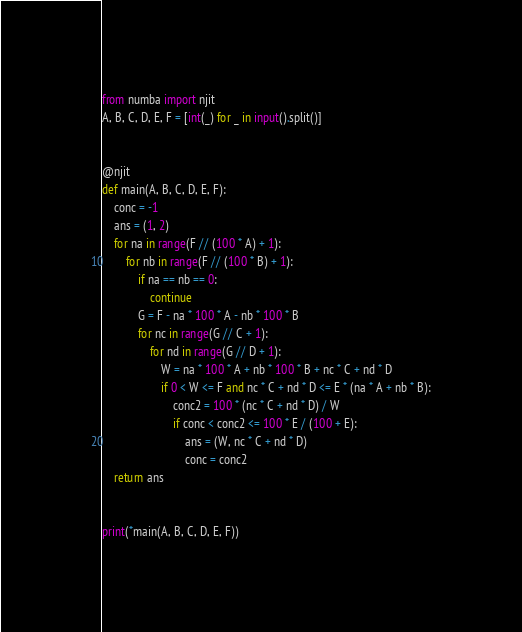Convert code to text. <code><loc_0><loc_0><loc_500><loc_500><_Python_>from numba import njit
A, B, C, D, E, F = [int(_) for _ in input().split()]


@njit
def main(A, B, C, D, E, F):
    conc = -1
    ans = (1, 2)
    for na in range(F // (100 * A) + 1):
        for nb in range(F // (100 * B) + 1):
            if na == nb == 0:
                continue
            G = F - na * 100 * A - nb * 100 * B
            for nc in range(G // C + 1):
                for nd in range(G // D + 1):
                    W = na * 100 * A + nb * 100 * B + nc * C + nd * D
                    if 0 < W <= F and nc * C + nd * D <= E * (na * A + nb * B):
                        conc2 = 100 * (nc * C + nd * D) / W
                        if conc < conc2 <= 100 * E / (100 + E):
                            ans = (W, nc * C + nd * D)
                            conc = conc2
    return ans


print(*main(A, B, C, D, E, F))
</code> 